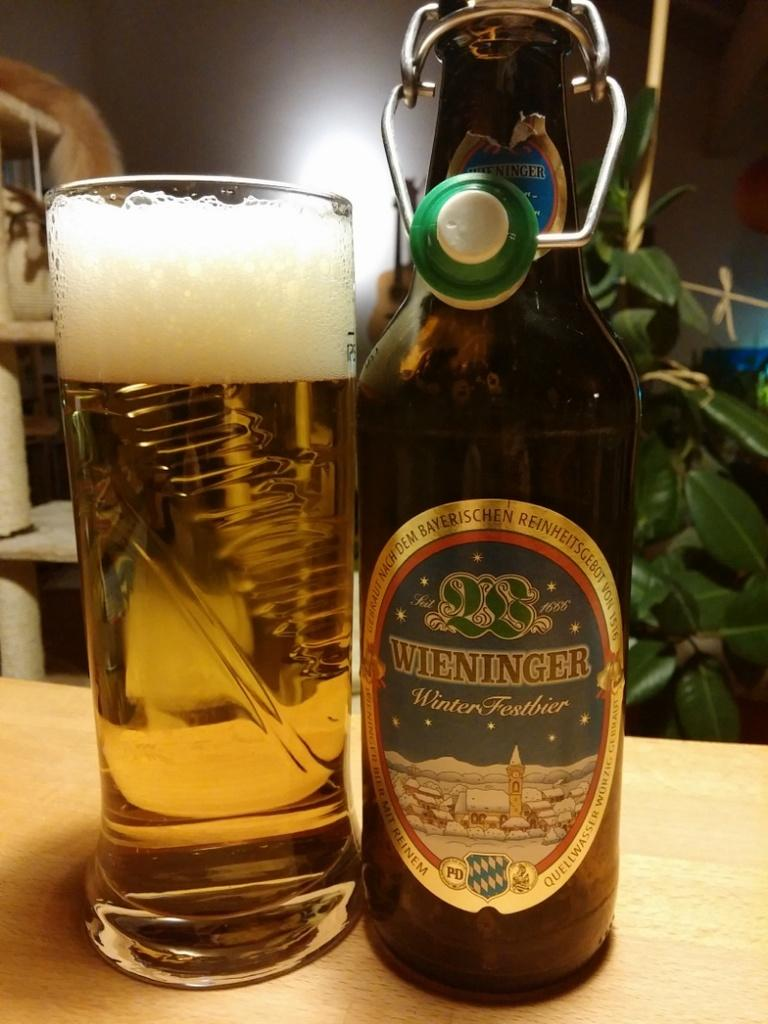<image>
Provide a brief description of the given image. A bottle of Weininger beer sits by a full glass of beer. 